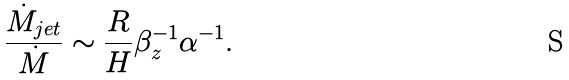<formula> <loc_0><loc_0><loc_500><loc_500>\frac { \dot { M } _ { j e t } } { \dot { M } } \sim \frac { R } { H } \beta _ { z } ^ { - 1 } \alpha ^ { - 1 } .</formula> 